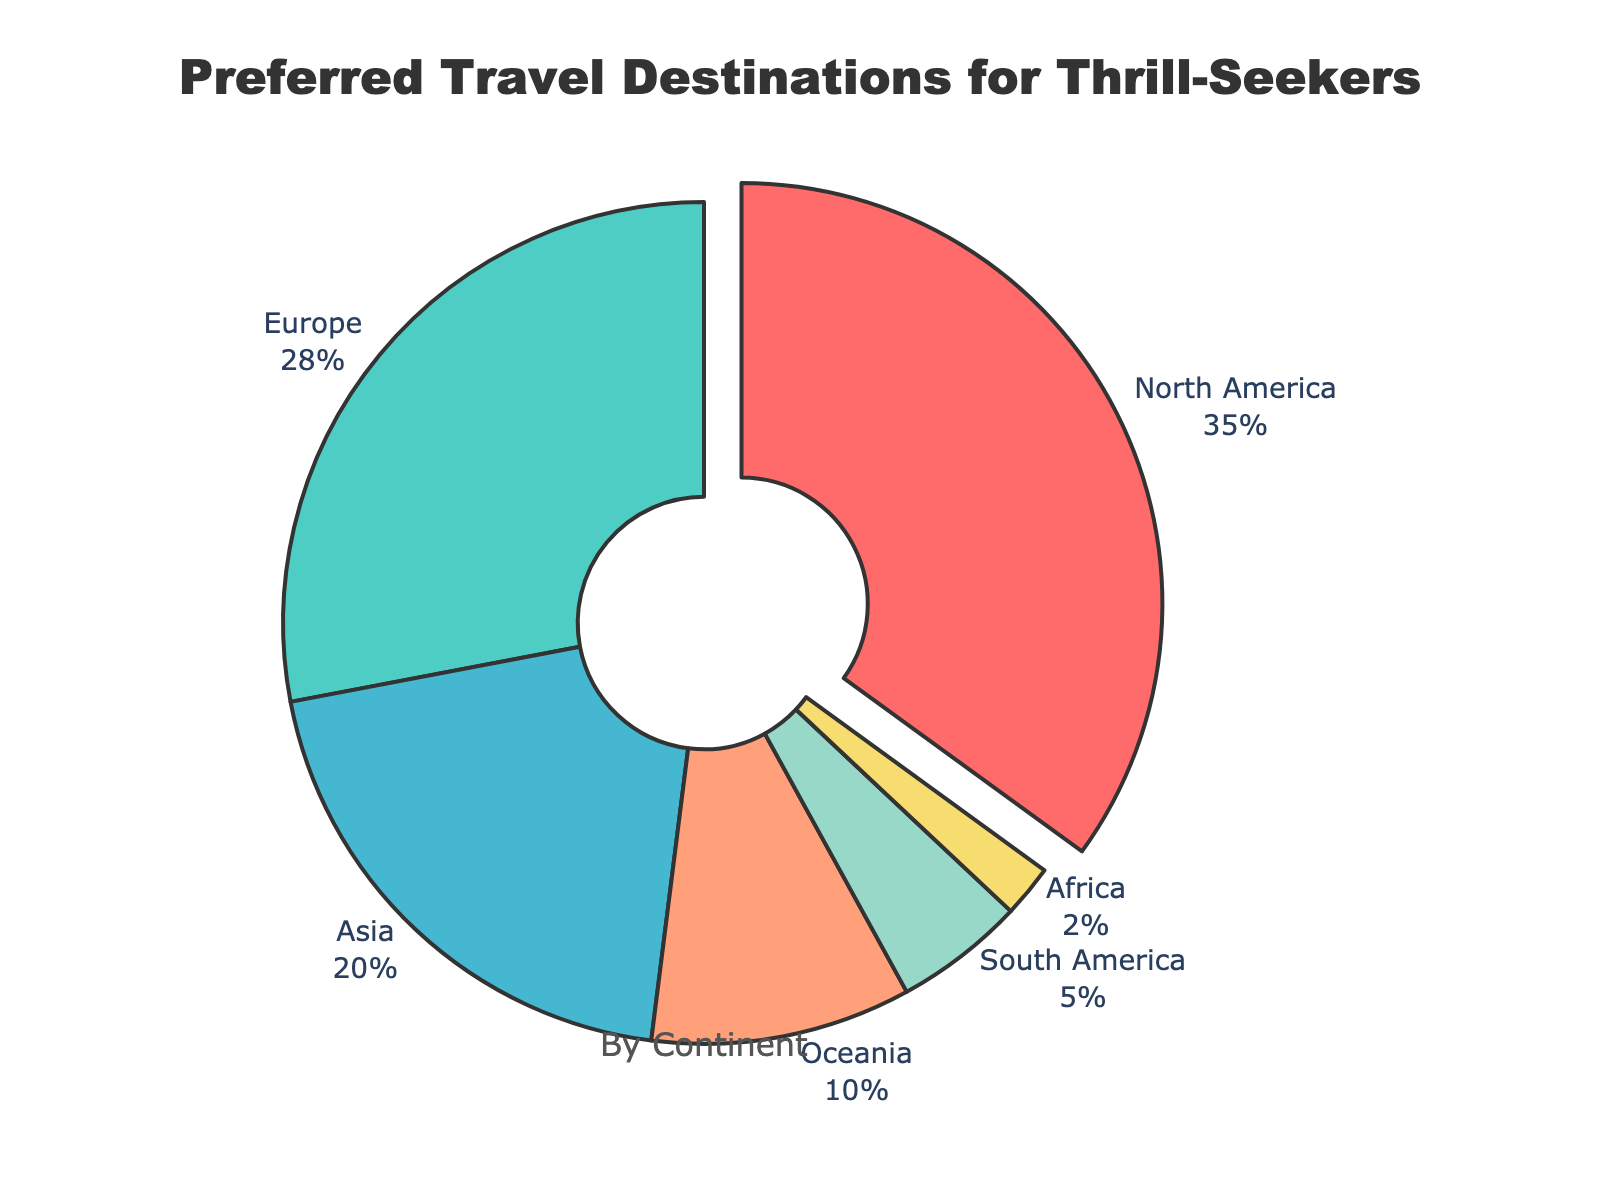What is the most preferred travel destination for thrill-seekers? The pie chart shows the segments for each continent, with the segment for North America being the largest.
Answer: North America Which continent has the least preferred travel destination for thrill-seekers? The pie chart shows a very small segment for Africa, indicating it has the lowest percentage.
Answer: Africa What is the combined percentage of Asia and Oceania? The segment for Asia is 20% and the segment for Oceania is 10%. Adding these together gives 20% + 10% = 30%.
Answer: 30% How much more preferred is North America compared to South America? The segment for North America is 35%, and for South America, it is 5%. The difference is 35% - 5% = 30%.
Answer: 30% Which continent(s) have a larger percentage than Europe but smaller than North America? North America has 35%, and Europe has 28%. Asia with 20% falls between these percentages.
Answer: Asia What is the percentage difference between the most and least preferred continents? North America is the most preferred at 35% and Africa is the least preferred at 2%. The difference is 35% - 2% = 33%.
Answer: 33% What percentage of thrill-seekers prefer destinations outside of Europe and Asia? Europe has 28%, and Asia has 20%, so together they make 28% + 20% = 48%. The total percentage for other continents is 100% - 48% = 52%.
Answer: 52% Identify the two continents with a combined percentage equal to North America's percentage. North America has 35%. The combination closest to 35% is Europe (28%) and South America (5%), which together make 28% + 5% = 33% but this exact match is not possible.
Answer: Not applicable Which continents have less than 10% share each? Both South America (5%) and Africa (2%) have less than 10% shares in the pie chart.
Answer: South America, Africa How many continents have a percentage larger than 25%? North America (35%) and Europe (28%) both have percentages larger than 25%.
Answer: 2 